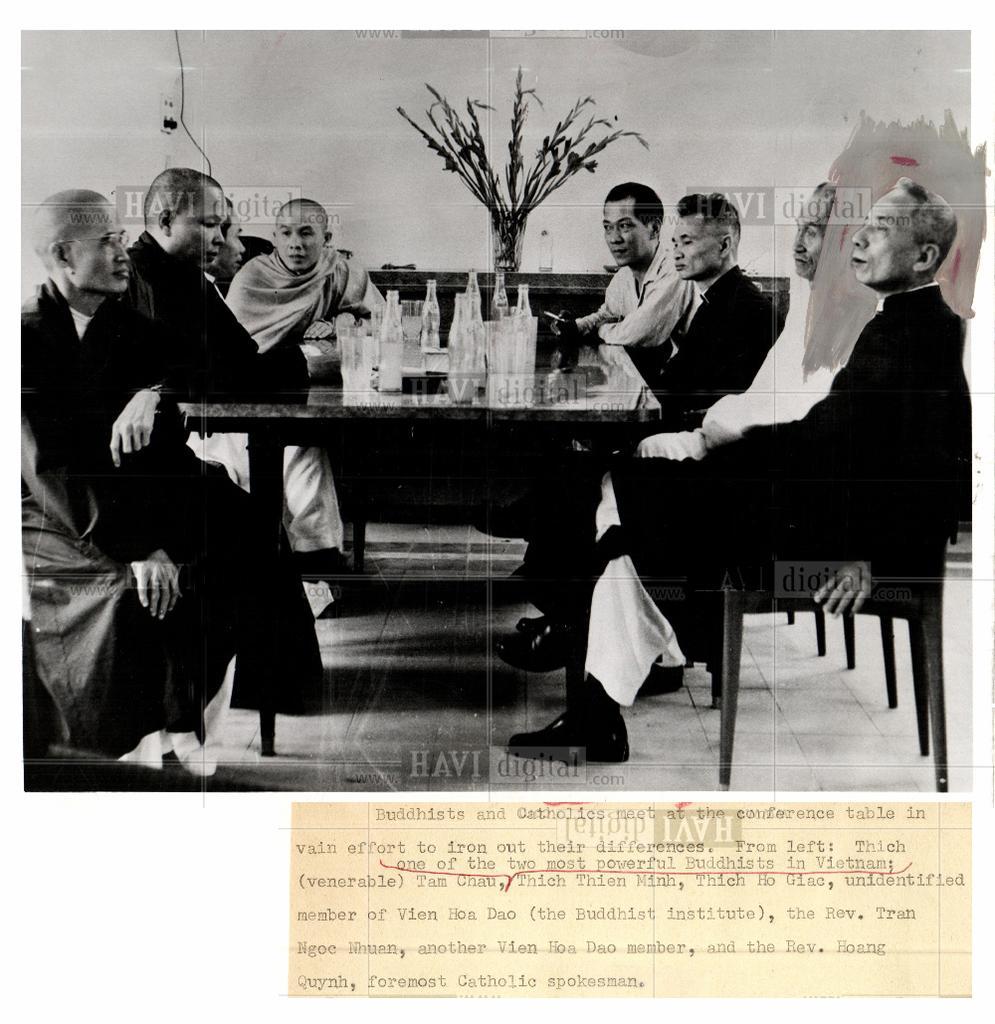Can you describe this image briefly? In the photo people are sitting on chairs. In the middle there is a table on the table there are bottles. The photo is a black and white image. In the background there is a pot. In the bottom there are texts. 